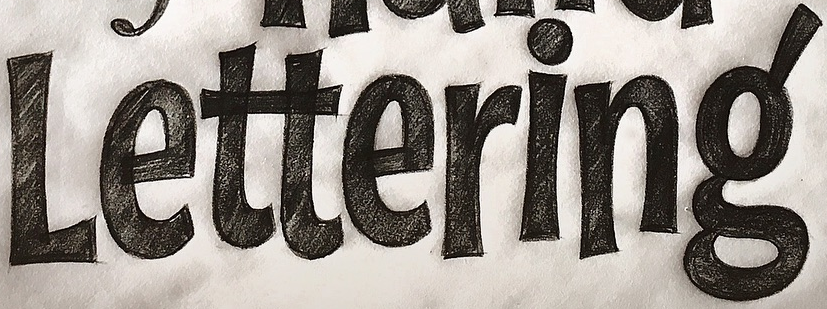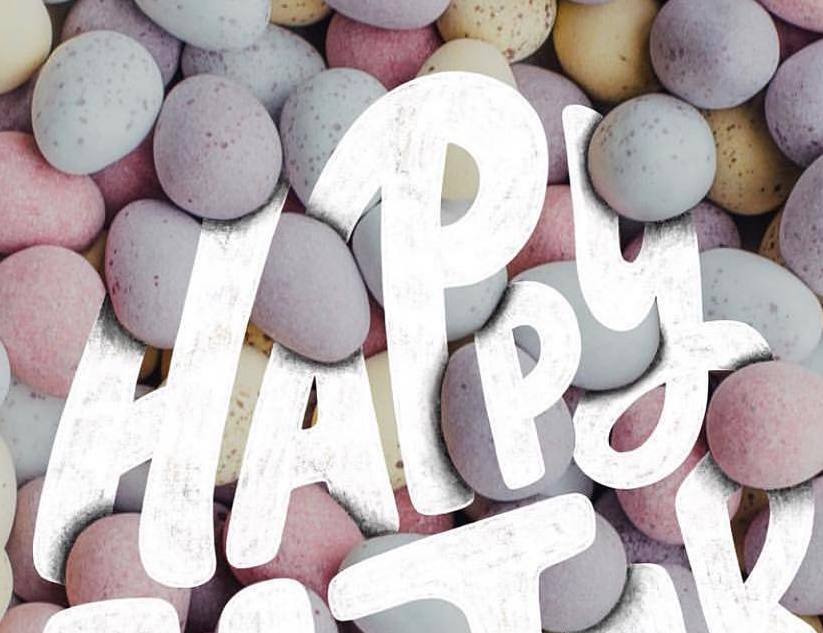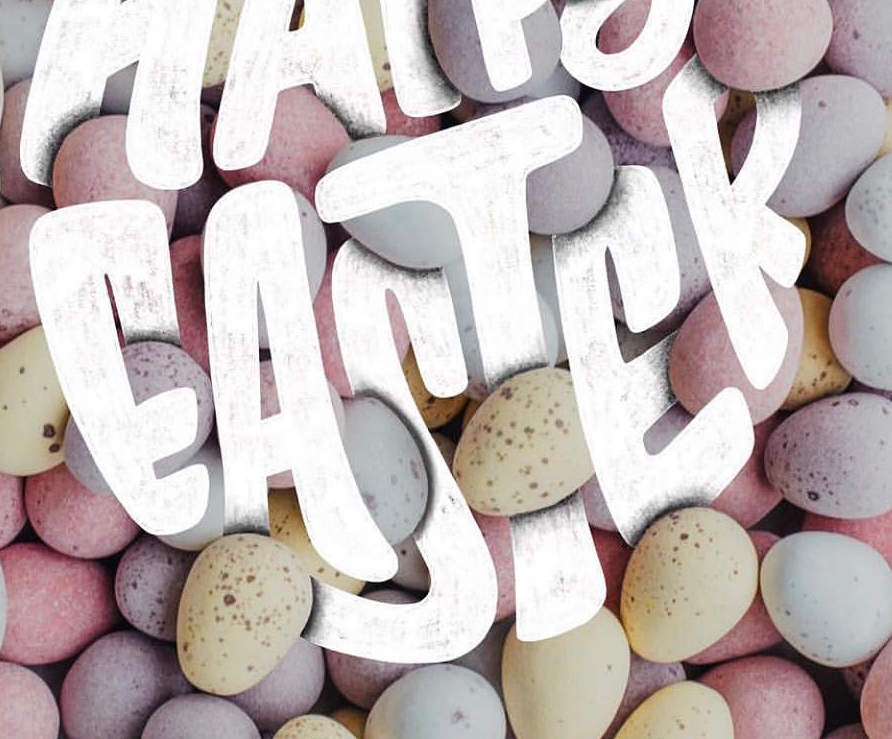What words are shown in these images in order, separated by a semicolon? Lettering; HAPPY; EASTER 